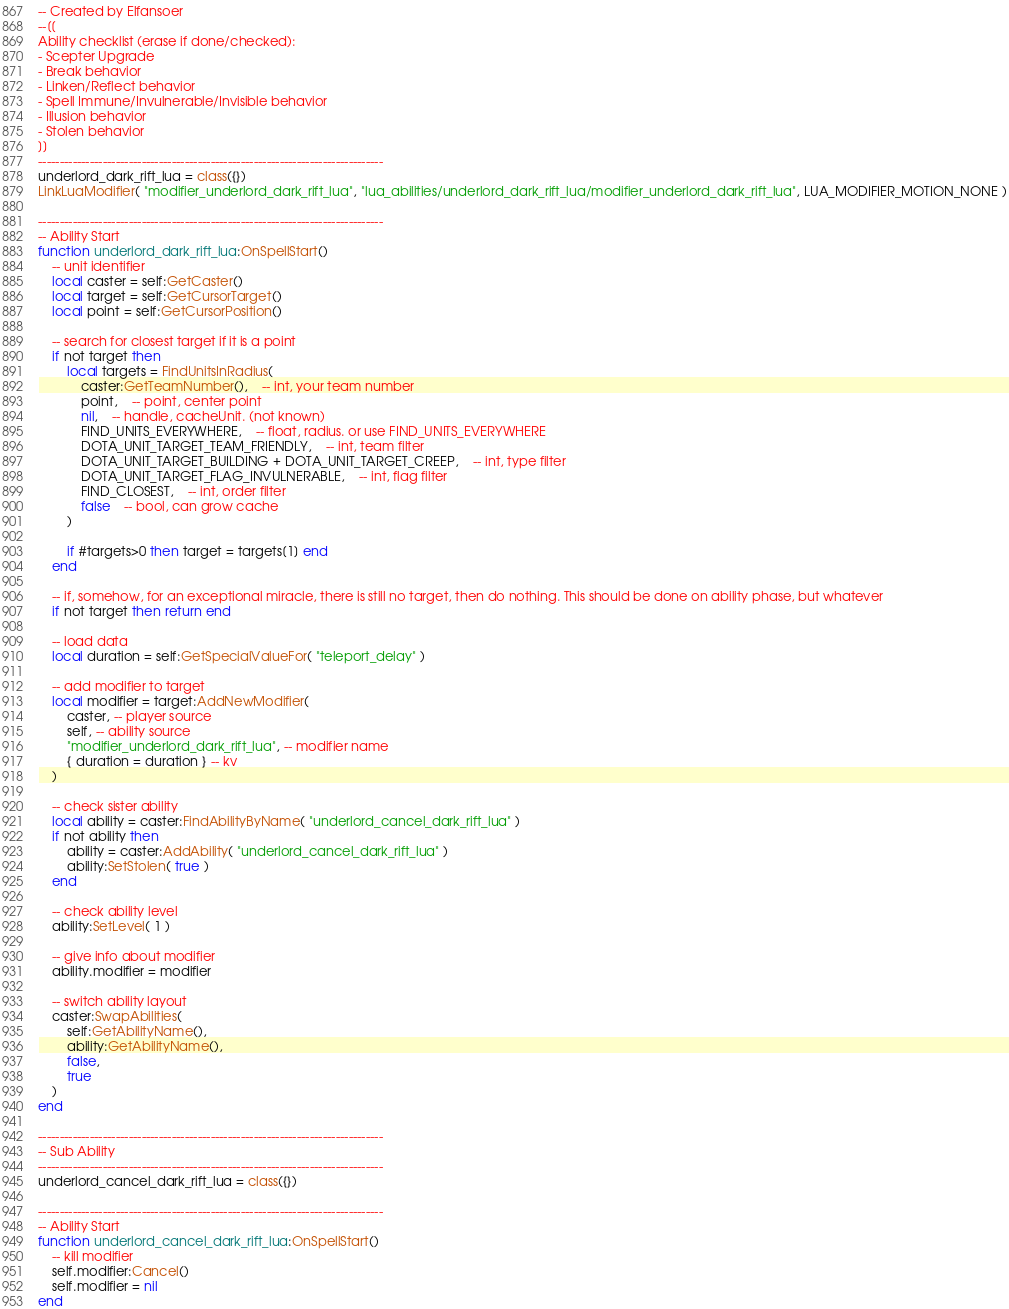<code> <loc_0><loc_0><loc_500><loc_500><_Lua_>-- Created by Elfansoer
--[[
Ability checklist (erase if done/checked):
- Scepter Upgrade
- Break behavior
- Linken/Reflect behavior
- Spell Immune/Invulnerable/Invisible behavior
- Illusion behavior
- Stolen behavior
]]
--------------------------------------------------------------------------------
underlord_dark_rift_lua = class({})
LinkLuaModifier( "modifier_underlord_dark_rift_lua", "lua_abilities/underlord_dark_rift_lua/modifier_underlord_dark_rift_lua", LUA_MODIFIER_MOTION_NONE )

--------------------------------------------------------------------------------
-- Ability Start
function underlord_dark_rift_lua:OnSpellStart()
	-- unit identifier
	local caster = self:GetCaster()
	local target = self:GetCursorTarget()
	local point = self:GetCursorPosition()

	-- search for closest target if it is a point
	if not target then
		local targets = FindUnitsInRadius(
			caster:GetTeamNumber(),	-- int, your team number
			point,	-- point, center point
			nil,	-- handle, cacheUnit. (not known)
			FIND_UNITS_EVERYWHERE,	-- float, radius. or use FIND_UNITS_EVERYWHERE
			DOTA_UNIT_TARGET_TEAM_FRIENDLY,	-- int, team filter
			DOTA_UNIT_TARGET_BUILDING + DOTA_UNIT_TARGET_CREEP,	-- int, type filter
			DOTA_UNIT_TARGET_FLAG_INVULNERABLE,	-- int, flag filter
			FIND_CLOSEST,	-- int, order filter
			false	-- bool, can grow cache
		)

		if #targets>0 then target = targets[1] end
	end

	-- if, somehow, for an exceptional miracle, there is still no target, then do nothing. This should be done on ability phase, but whatever
	if not target then return end

	-- load data
	local duration = self:GetSpecialValueFor( "teleport_delay" )

	-- add modifier to target
	local modifier = target:AddNewModifier(
		caster, -- player source
		self, -- ability source
		"modifier_underlord_dark_rift_lua", -- modifier name
		{ duration = duration } -- kv
	)

	-- check sister ability
	local ability = caster:FindAbilityByName( "underlord_cancel_dark_rift_lua" )
	if not ability then
		ability = caster:AddAbility( "underlord_cancel_dark_rift_lua" )
		ability:SetStolen( true )
	end

	-- check ability level
	ability:SetLevel( 1 )

	-- give info about modifier
	ability.modifier = modifier

	-- switch ability layout
	caster:SwapAbilities(
		self:GetAbilityName(),
		ability:GetAbilityName(),
		false,
		true
	)
end

--------------------------------------------------------------------------------
-- Sub Ability
--------------------------------------------------------------------------------
underlord_cancel_dark_rift_lua = class({})

--------------------------------------------------------------------------------
-- Ability Start
function underlord_cancel_dark_rift_lua:OnSpellStart()
	-- kill modifier
	self.modifier:Cancel()
	self.modifier = nil
end</code> 